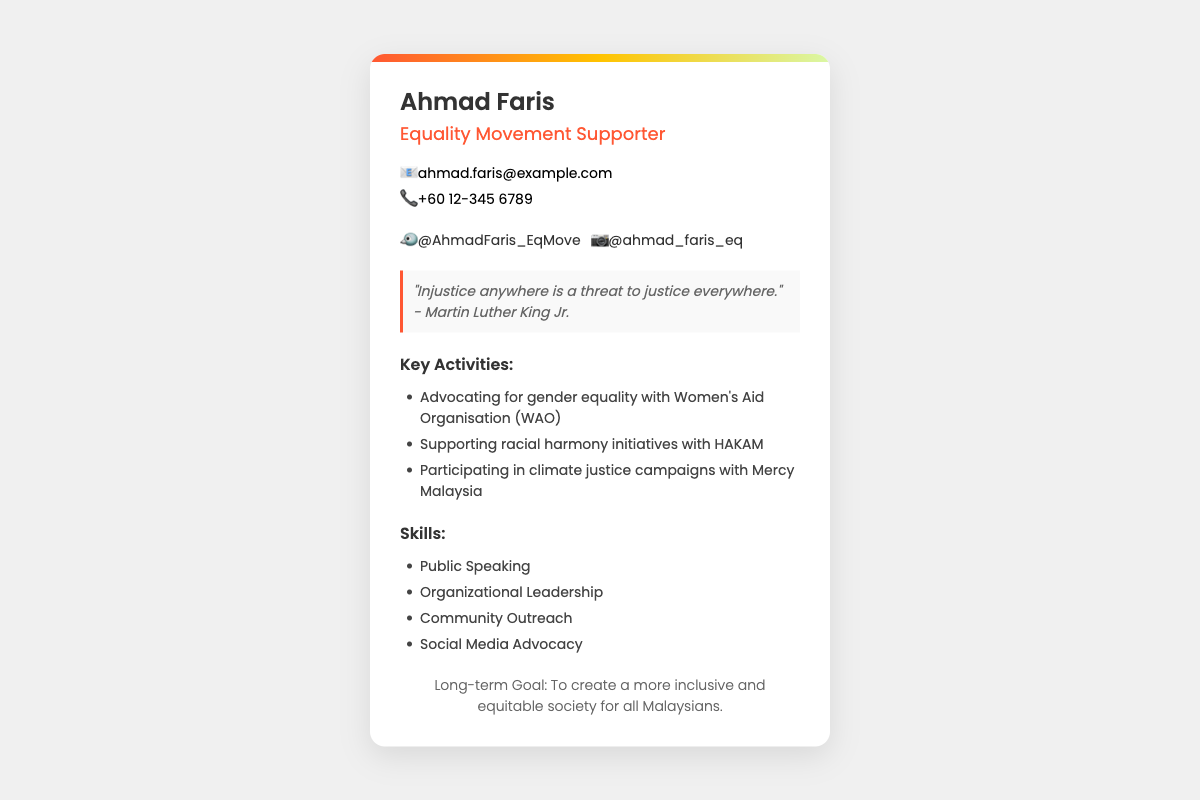What is the name of the supporter? The name listed on the business card is Ahmad Faris.
Answer: Ahmad Faris What is Ahmad Faris's occupation? The card states that Ahmad Faris is an Equality Movement Supporter.
Answer: Equality Movement Supporter What is the email address provided? The email address on the card is specified under contact information.
Answer: ahmad.faris@example.com What is the phone number listed? The phone number is given in the contact information section of the card.
Answer: +60 12-345 6789 What are the social media platforms Ahmad Faris is on? The social media section includes links to Twitter and Instagram.
Answer: Twitter and Instagram Which organization does Ahmad Faris advocate for gender equality with? The document mentions the Women's Aid Organisation (WAO) for gender equality advocacy.
Answer: Women's Aid Organisation (WAO) What is the long-term goal stated in the document? The goal is outlined towards the end of the card, describing aspirations for society.
Answer: To create a more inclusive and equitable society for all Malaysians What quote is mentioned on the card? The quote section includes a notable quote attributed to Martin Luther King Jr.
Answer: "Injustice anywhere is a threat to justice everywhere." How many key activities are listed on the card? The list of key activities under that section indicates three distinct activities.
Answer: Three Which skill is mentioned first in the skills section? The skills are listed in a specific order, with the first one being a key focus.
Answer: Public Speaking 